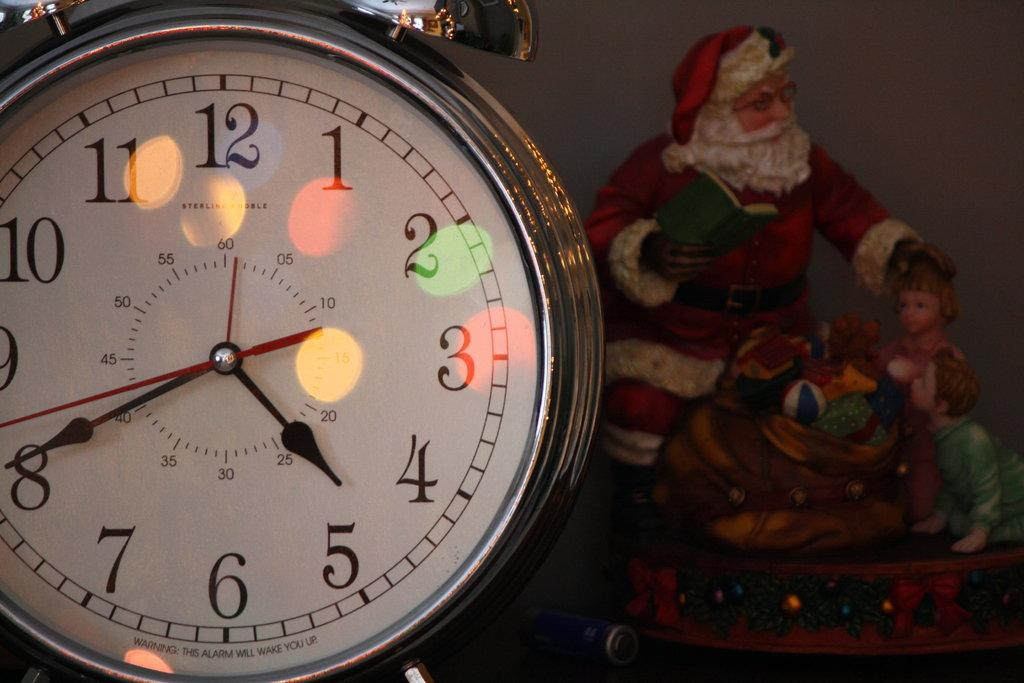<image>
Create a compact narrative representing the image presented. The small hand of a watch sits between the numbers 4 and 5. 